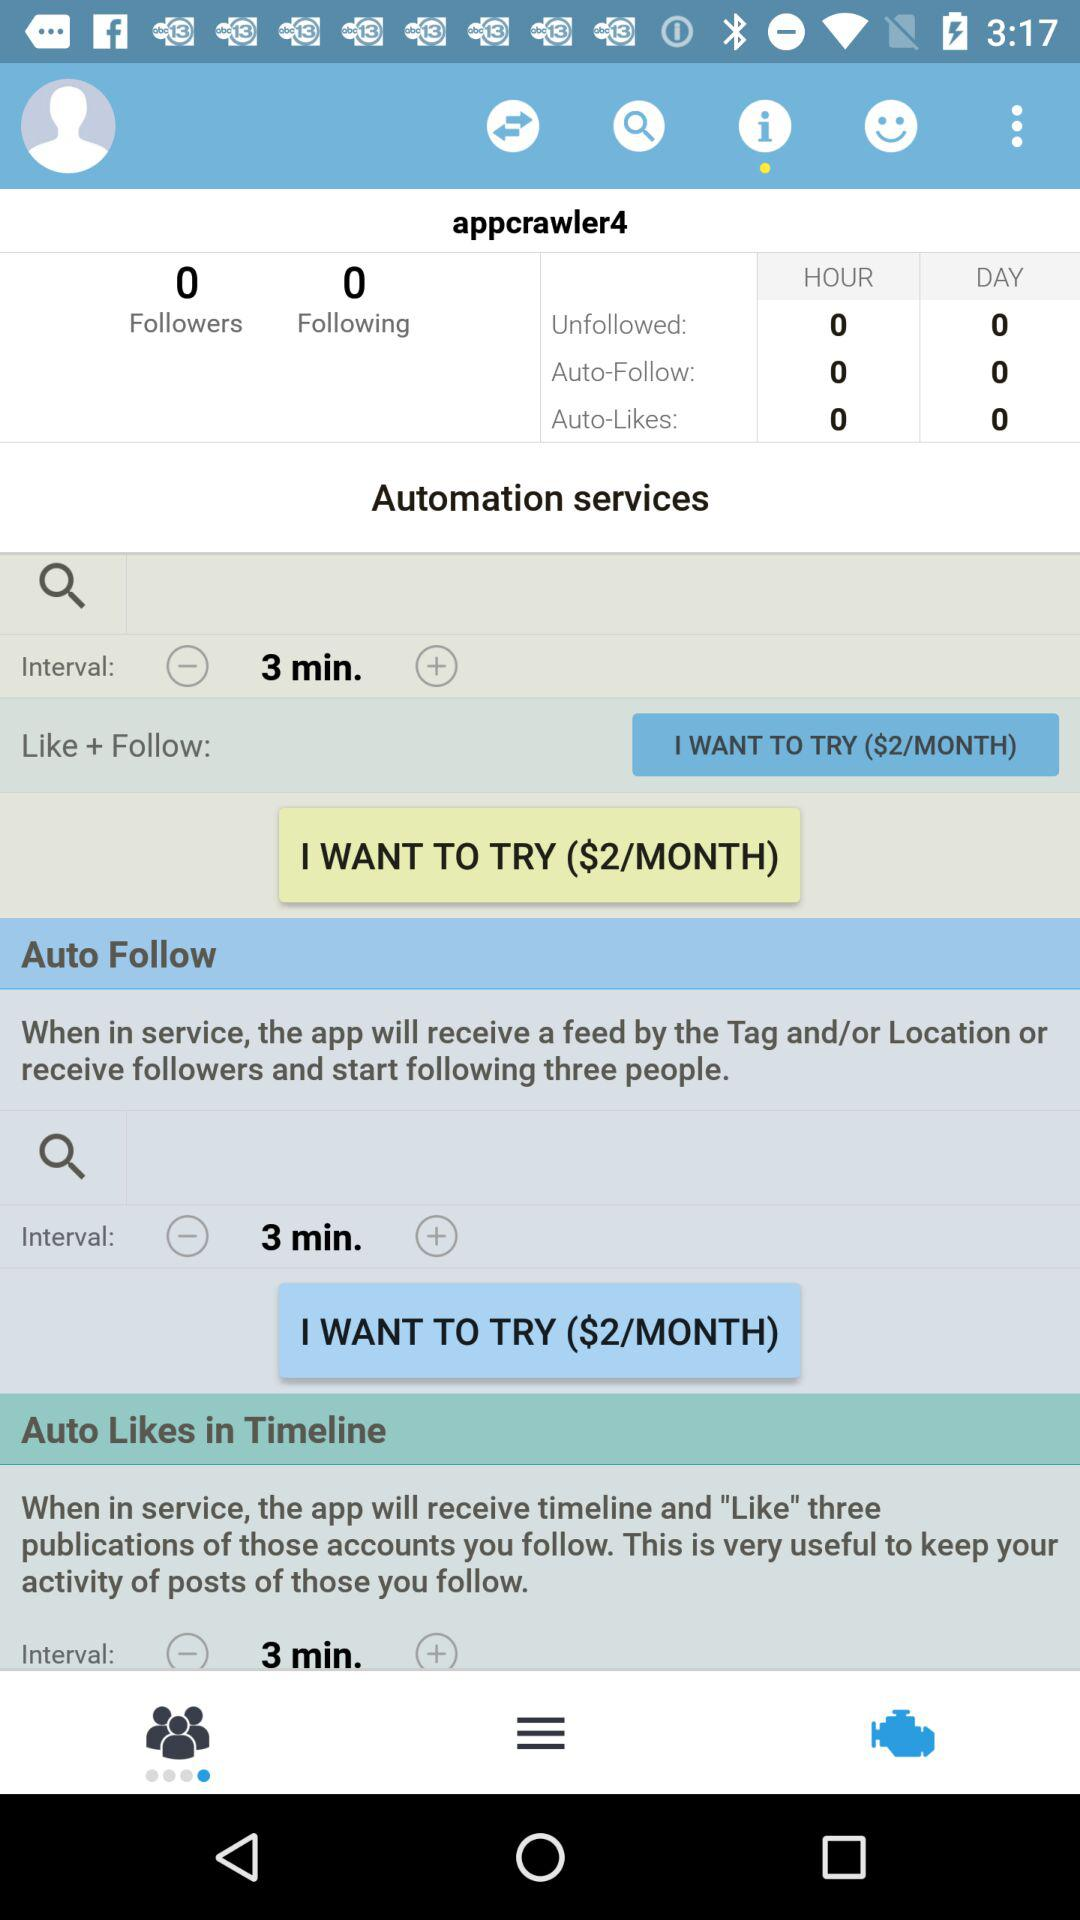How many Auto-Likes are there in a day? There are 0 Auto-Likes. 